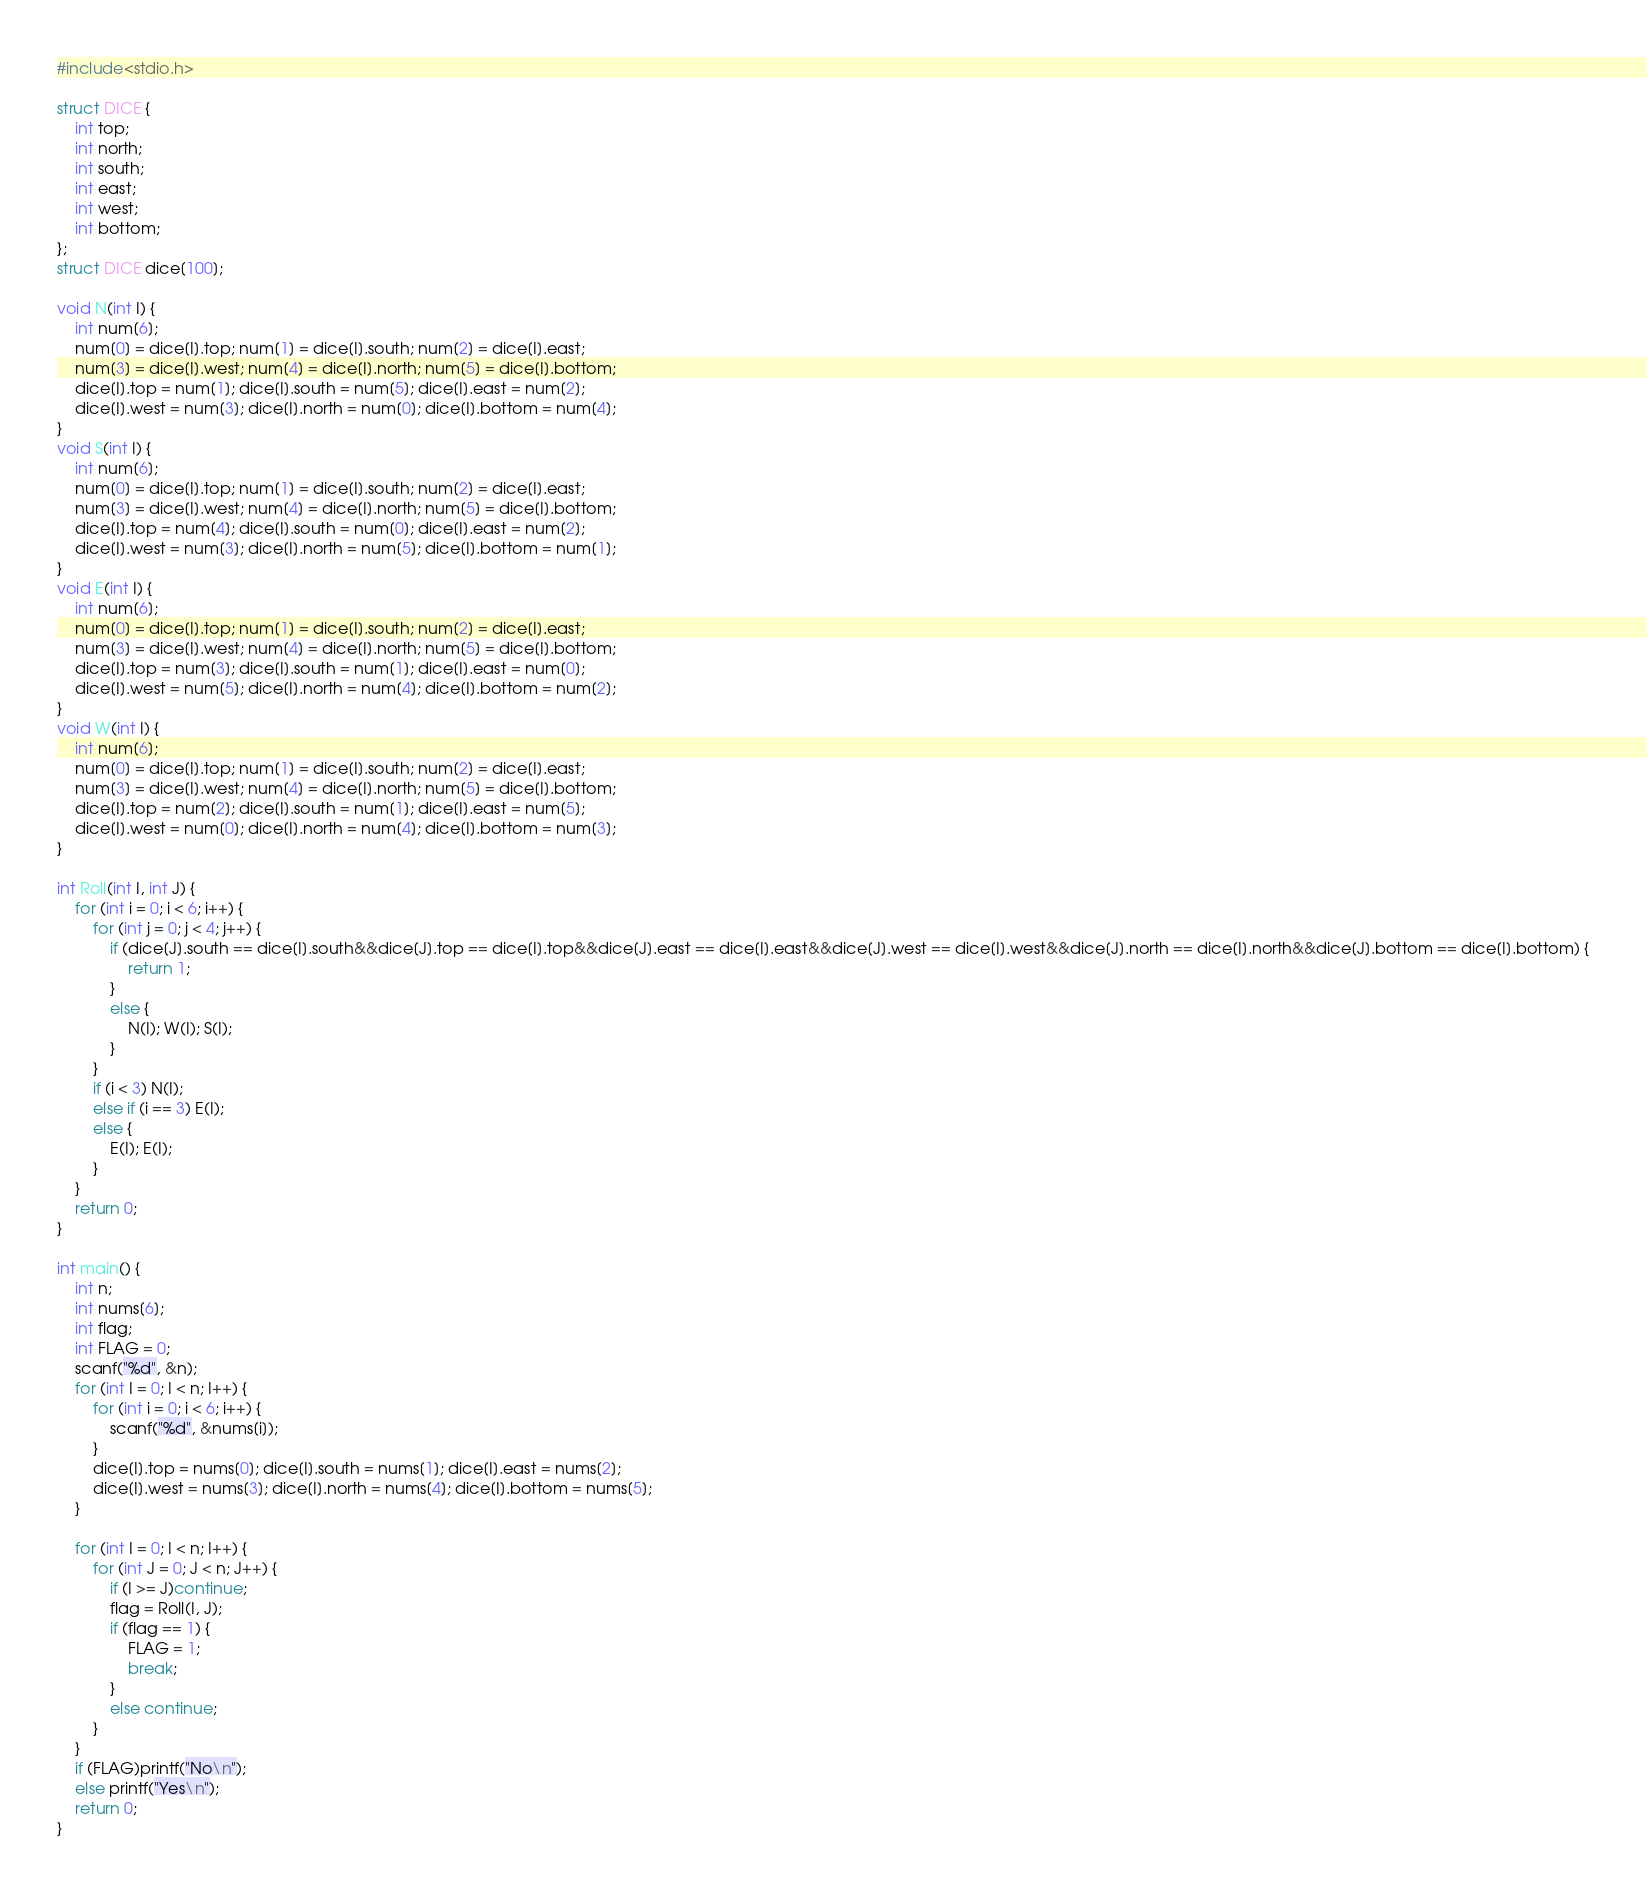Convert code to text. <code><loc_0><loc_0><loc_500><loc_500><_C_>#include<stdio.h>

struct DICE {
	int top;
	int north;
	int south;
	int east;
	int west;
	int bottom;
};
struct DICE dice[100];

void N(int I) {
	int num[6];
	num[0] = dice[I].top; num[1] = dice[I].south; num[2] = dice[I].east;
	num[3] = dice[I].west; num[4] = dice[I].north; num[5] = dice[I].bottom;
	dice[I].top = num[1]; dice[I].south = num[5]; dice[I].east = num[2];
	dice[I].west = num[3]; dice[I].north = num[0]; dice[I].bottom = num[4];
}
void S(int I) {
	int num[6];
	num[0] = dice[I].top; num[1] = dice[I].south; num[2] = dice[I].east;
	num[3] = dice[I].west; num[4] = dice[I].north; num[5] = dice[I].bottom;
	dice[I].top = num[4]; dice[I].south = num[0]; dice[I].east = num[2];
	dice[I].west = num[3]; dice[I].north = num[5]; dice[I].bottom = num[1];
}
void E(int I) {
	int num[6];
	num[0] = dice[I].top; num[1] = dice[I].south; num[2] = dice[I].east;
	num[3] = dice[I].west; num[4] = dice[I].north; num[5] = dice[I].bottom;
	dice[I].top = num[3]; dice[I].south = num[1]; dice[I].east = num[0];
	dice[I].west = num[5]; dice[I].north = num[4]; dice[I].bottom = num[2];
}
void W(int I) {
	int num[6];
	num[0] = dice[I].top; num[1] = dice[I].south; num[2] = dice[I].east;
	num[3] = dice[I].west; num[4] = dice[I].north; num[5] = dice[I].bottom;
	dice[I].top = num[2]; dice[I].south = num[1]; dice[I].east = num[5];
	dice[I].west = num[0]; dice[I].north = num[4]; dice[I].bottom = num[3];
}

int Roll(int I, int J) {
	for (int i = 0; i < 6; i++) {
		for (int j = 0; j < 4; j++) {
			if (dice[J].south == dice[I].south&&dice[J].top == dice[I].top&&dice[J].east == dice[I].east&&dice[J].west == dice[I].west&&dice[J].north == dice[I].north&&dice[J].bottom == dice[I].bottom) {
				return 1;
			}
			else {
				N(I); W(I); S(I);
			}
		}
		if (i < 3) N(I);
		else if (i == 3) E(I);
		else {
			E(I); E(I);
		}
	}
	return 0;
}

int main() {
	int n;
	int nums[6];
	int flag;
	int FLAG = 0;
	scanf("%d", &n);
	for (int I = 0; I < n; I++) {
		for (int i = 0; i < 6; i++) {
			scanf("%d", &nums[i]);
		}
		dice[I].top = nums[0]; dice[I].south = nums[1]; dice[I].east = nums[2];
		dice[I].west = nums[3]; dice[I].north = nums[4]; dice[I].bottom = nums[5];
	}

	for (int I = 0; I < n; I++) {
		for (int J = 0; J < n; J++) {
			if (I >= J)continue;
			flag = Roll(I, J);
			if (flag == 1) {
				FLAG = 1;
				break;
			}
			else continue;
		}
	}
	if (FLAG)printf("No\n");
	else printf("Yes\n");
	return 0;
}
</code> 